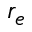Convert formula to latex. <formula><loc_0><loc_0><loc_500><loc_500>r _ { e }</formula> 